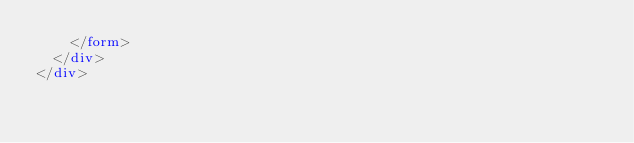Convert code to text. <code><loc_0><loc_0><loc_500><loc_500><_HTML_>    </form>
  </div>
</div>
</code> 